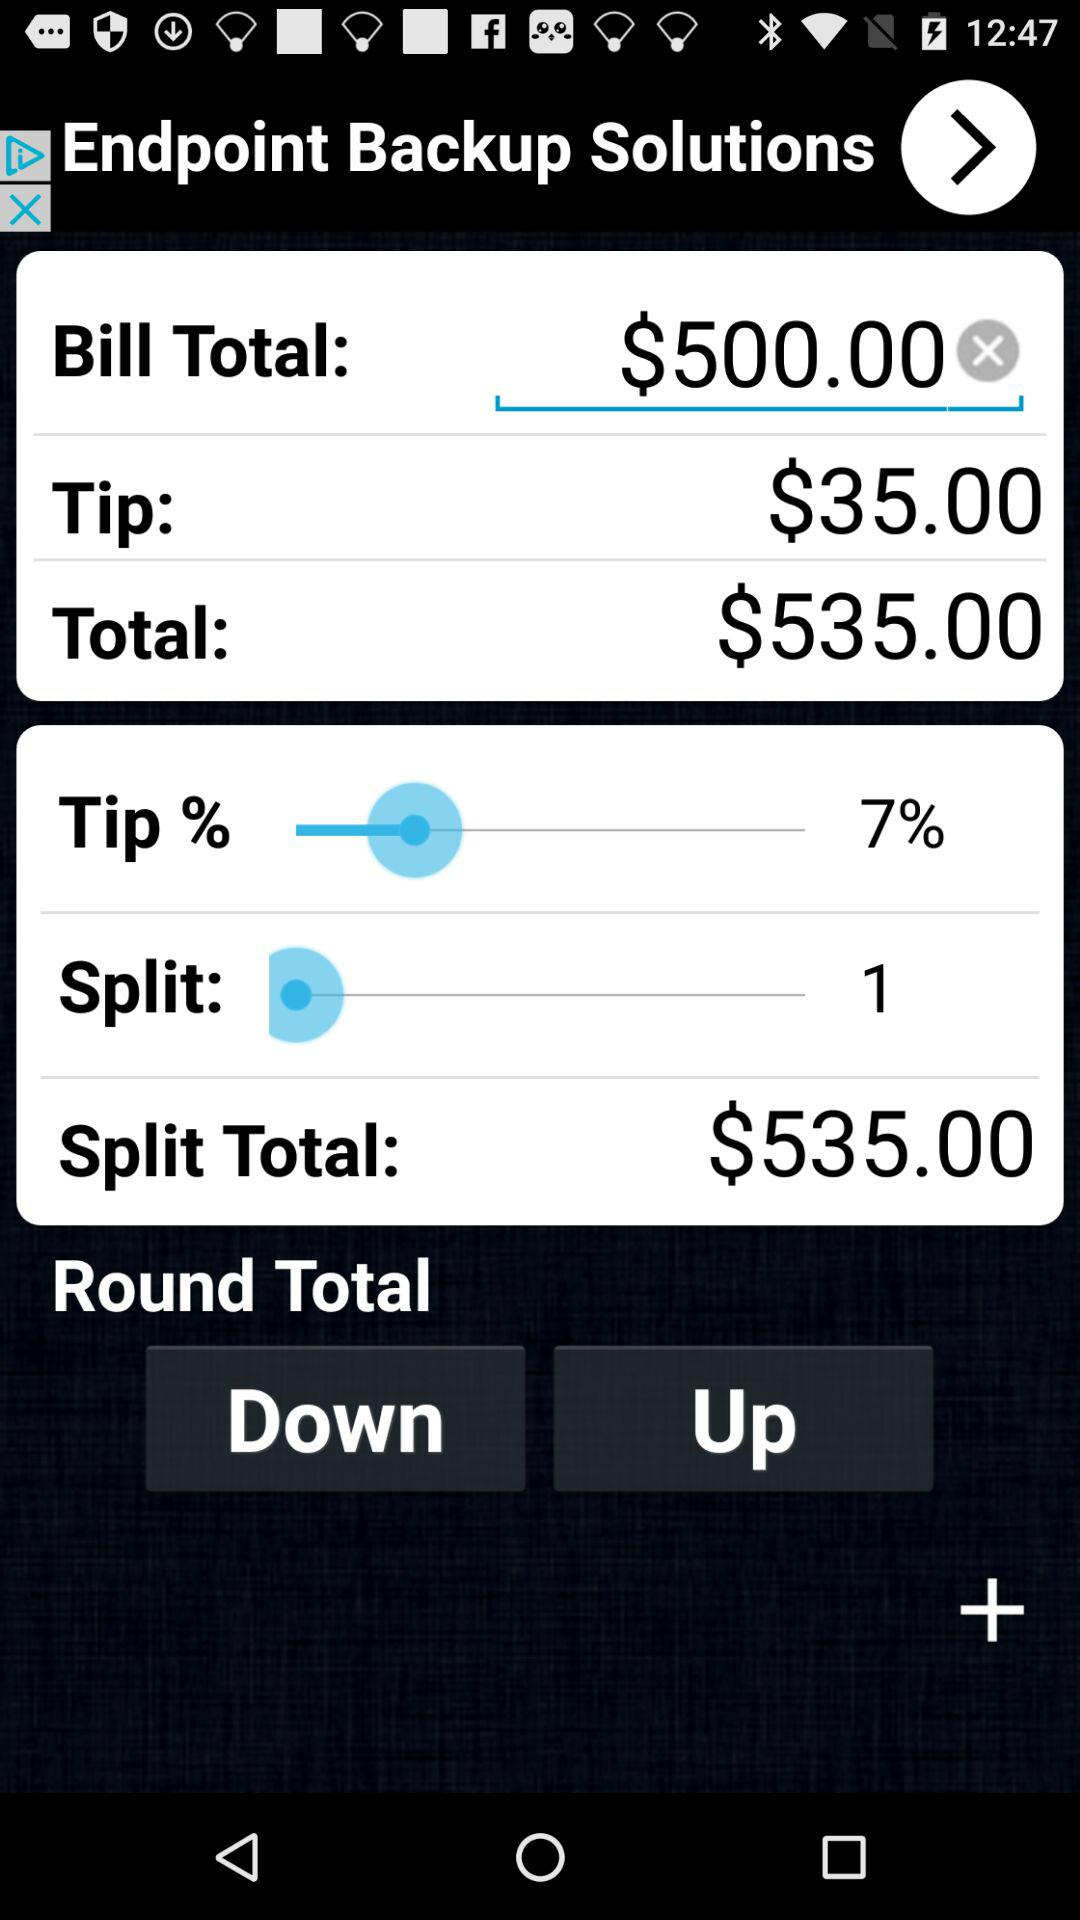How much is the tip if the bill is $500.00 and the tip percentage is 7%?
Answer the question using a single word or phrase. $35.00 